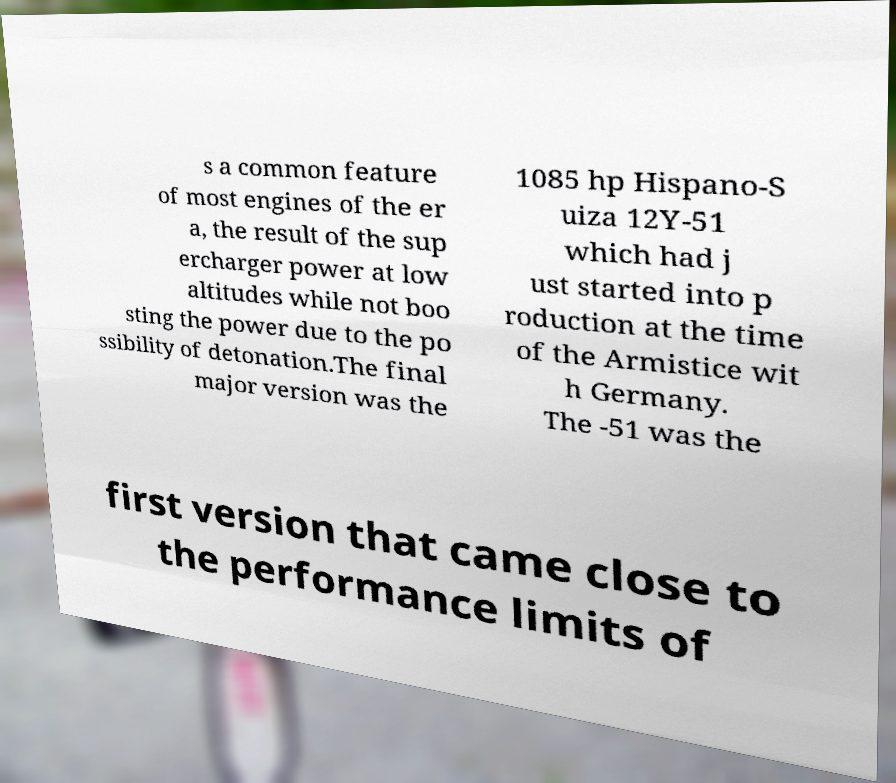What messages or text are displayed in this image? I need them in a readable, typed format. s a common feature of most engines of the er a, the result of the sup ercharger power at low altitudes while not boo sting the power due to the po ssibility of detonation.The final major version was the 1085 hp Hispano-S uiza 12Y-51 which had j ust started into p roduction at the time of the Armistice wit h Germany. The -51 was the first version that came close to the performance limits of 